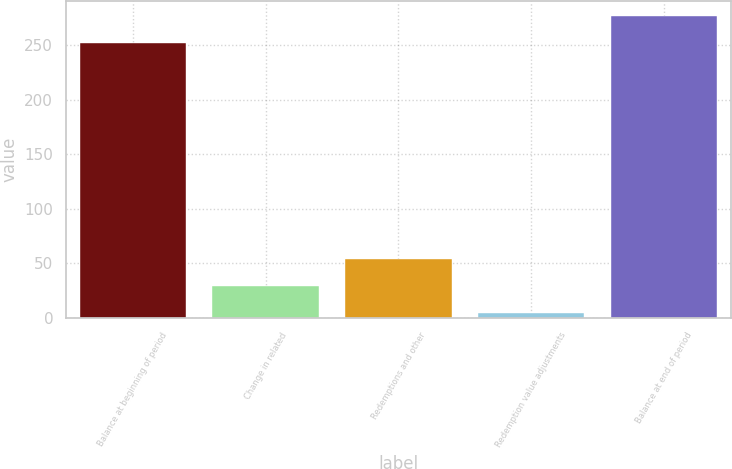<chart> <loc_0><loc_0><loc_500><loc_500><bar_chart><fcel>Balance at beginning of period<fcel>Change in related<fcel>Redemptions and other<fcel>Redemption value adjustments<fcel>Balance at end of period<nl><fcel>251.9<fcel>28.88<fcel>53.76<fcel>4<fcel>276.78<nl></chart> 